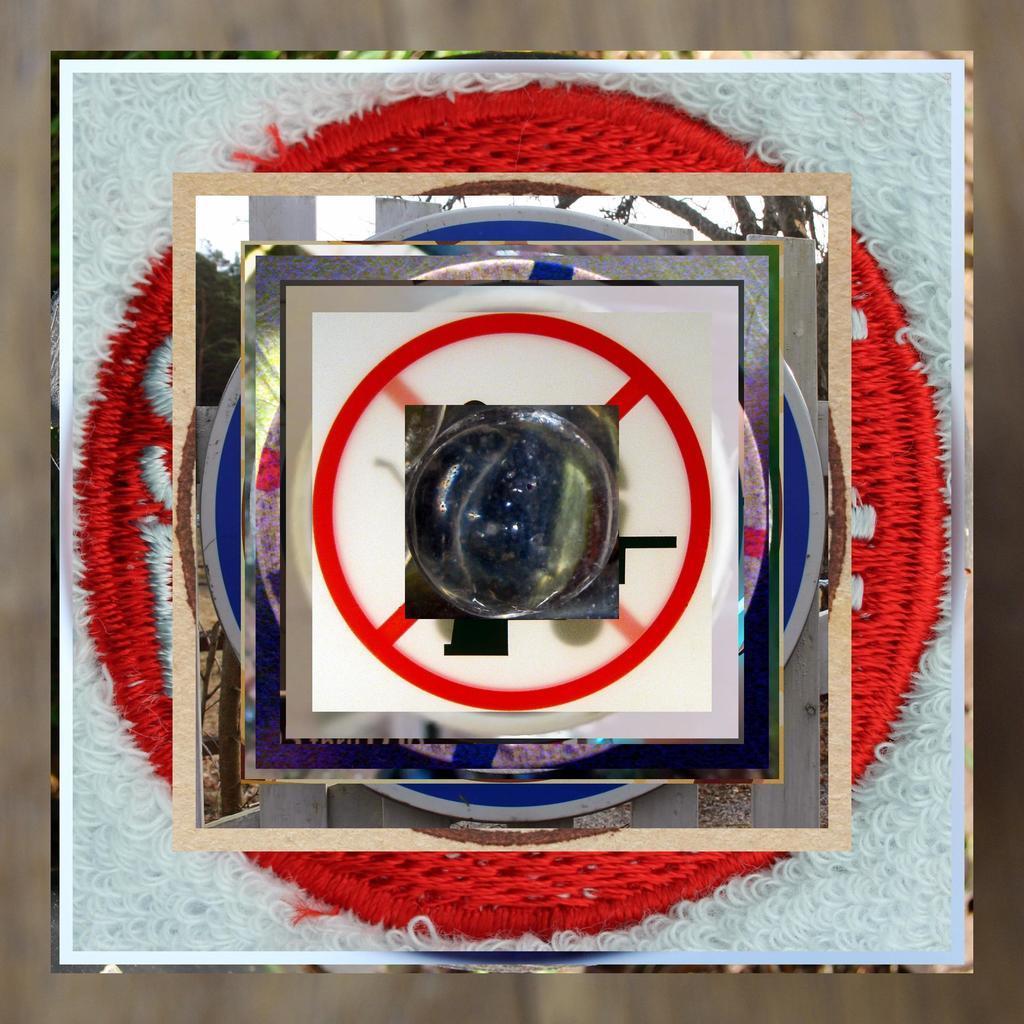How would you summarize this image in a sentence or two? In this image there is a glass material and in the middle of the image there is a marble, which is transparent in color and there is a circle. At the bottom of the image there is a woolen cloth which is white in color. In the background there is another cloth which is red in color. 